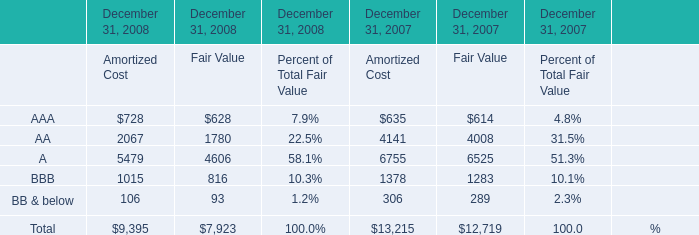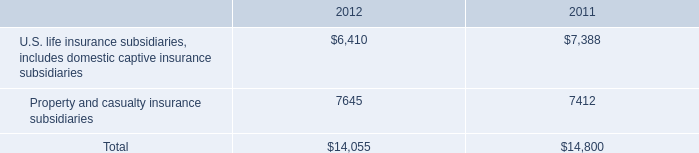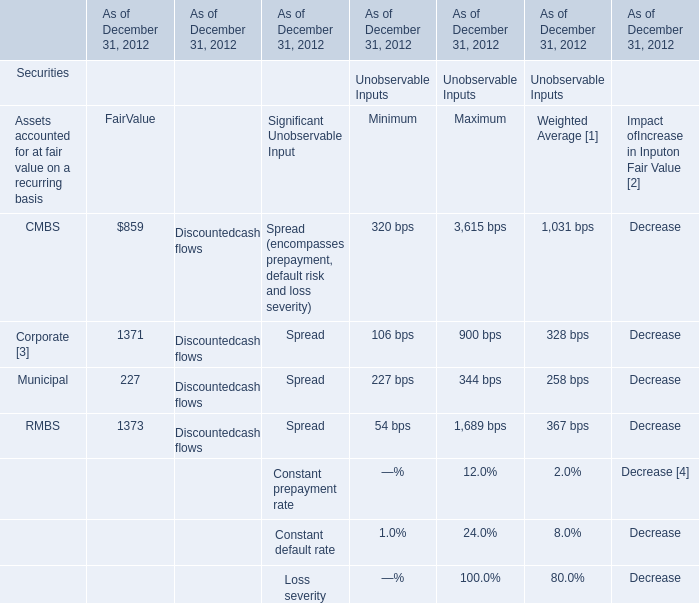What is the sum of A of December 31, 2008 Fair Value, and RMBS of As of December 31, 2012 FairValue ? 
Computations: (4606.0 + 1373.0)
Answer: 5979.0. 